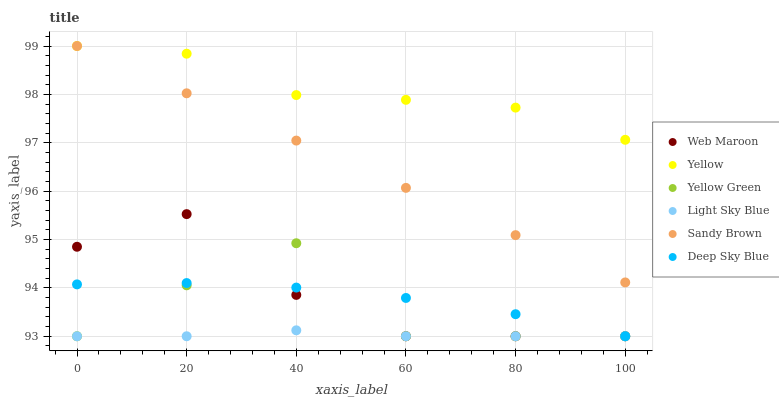Does Light Sky Blue have the minimum area under the curve?
Answer yes or no. Yes. Does Yellow have the maximum area under the curve?
Answer yes or no. Yes. Does Web Maroon have the minimum area under the curve?
Answer yes or no. No. Does Web Maroon have the maximum area under the curve?
Answer yes or no. No. Is Sandy Brown the smoothest?
Answer yes or no. Yes. Is Yellow Green the roughest?
Answer yes or no. Yes. Is Web Maroon the smoothest?
Answer yes or no. No. Is Web Maroon the roughest?
Answer yes or no. No. Does Yellow Green have the lowest value?
Answer yes or no. Yes. Does Yellow have the lowest value?
Answer yes or no. No. Does Sandy Brown have the highest value?
Answer yes or no. Yes. Does Web Maroon have the highest value?
Answer yes or no. No. Is Yellow Green less than Yellow?
Answer yes or no. Yes. Is Sandy Brown greater than Deep Sky Blue?
Answer yes or no. Yes. Does Yellow intersect Sandy Brown?
Answer yes or no. Yes. Is Yellow less than Sandy Brown?
Answer yes or no. No. Is Yellow greater than Sandy Brown?
Answer yes or no. No. Does Yellow Green intersect Yellow?
Answer yes or no. No. 